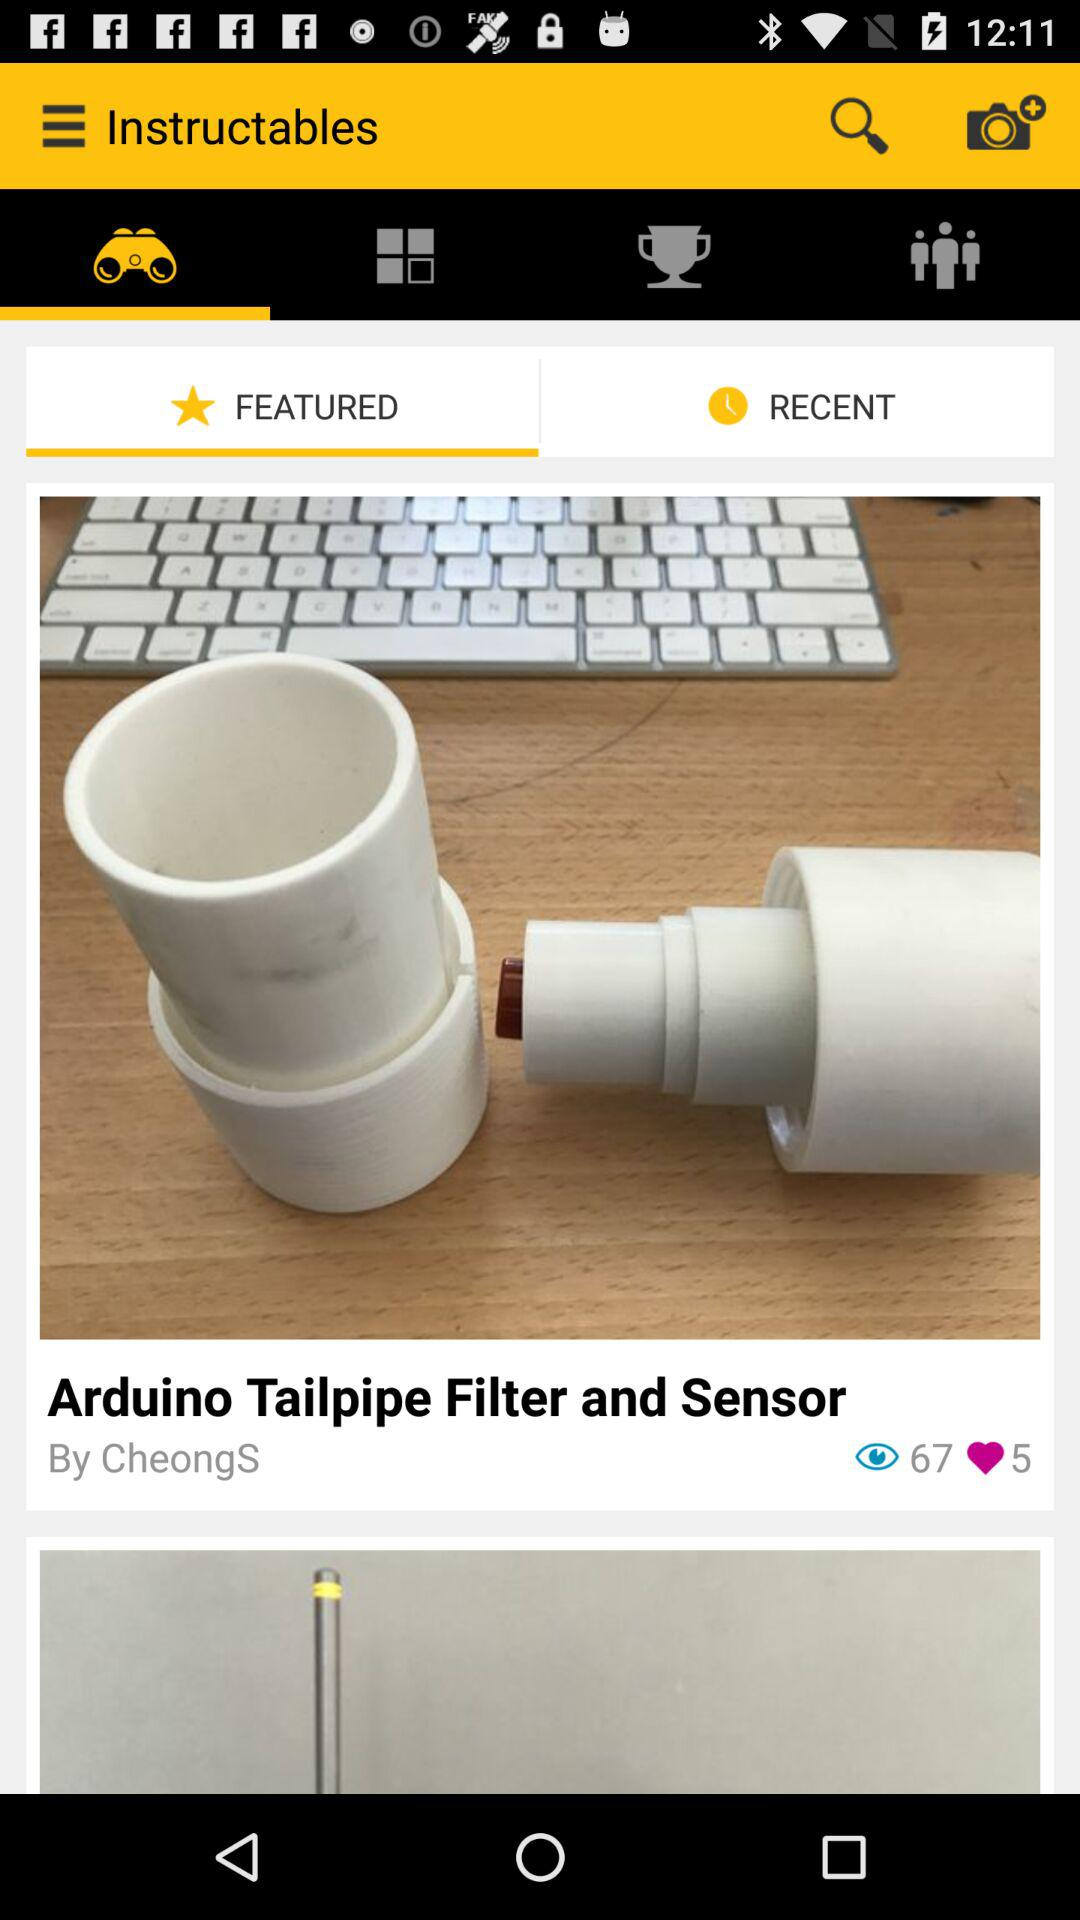How many likes in total are there of the post? There are 5 likes in total of the post. 